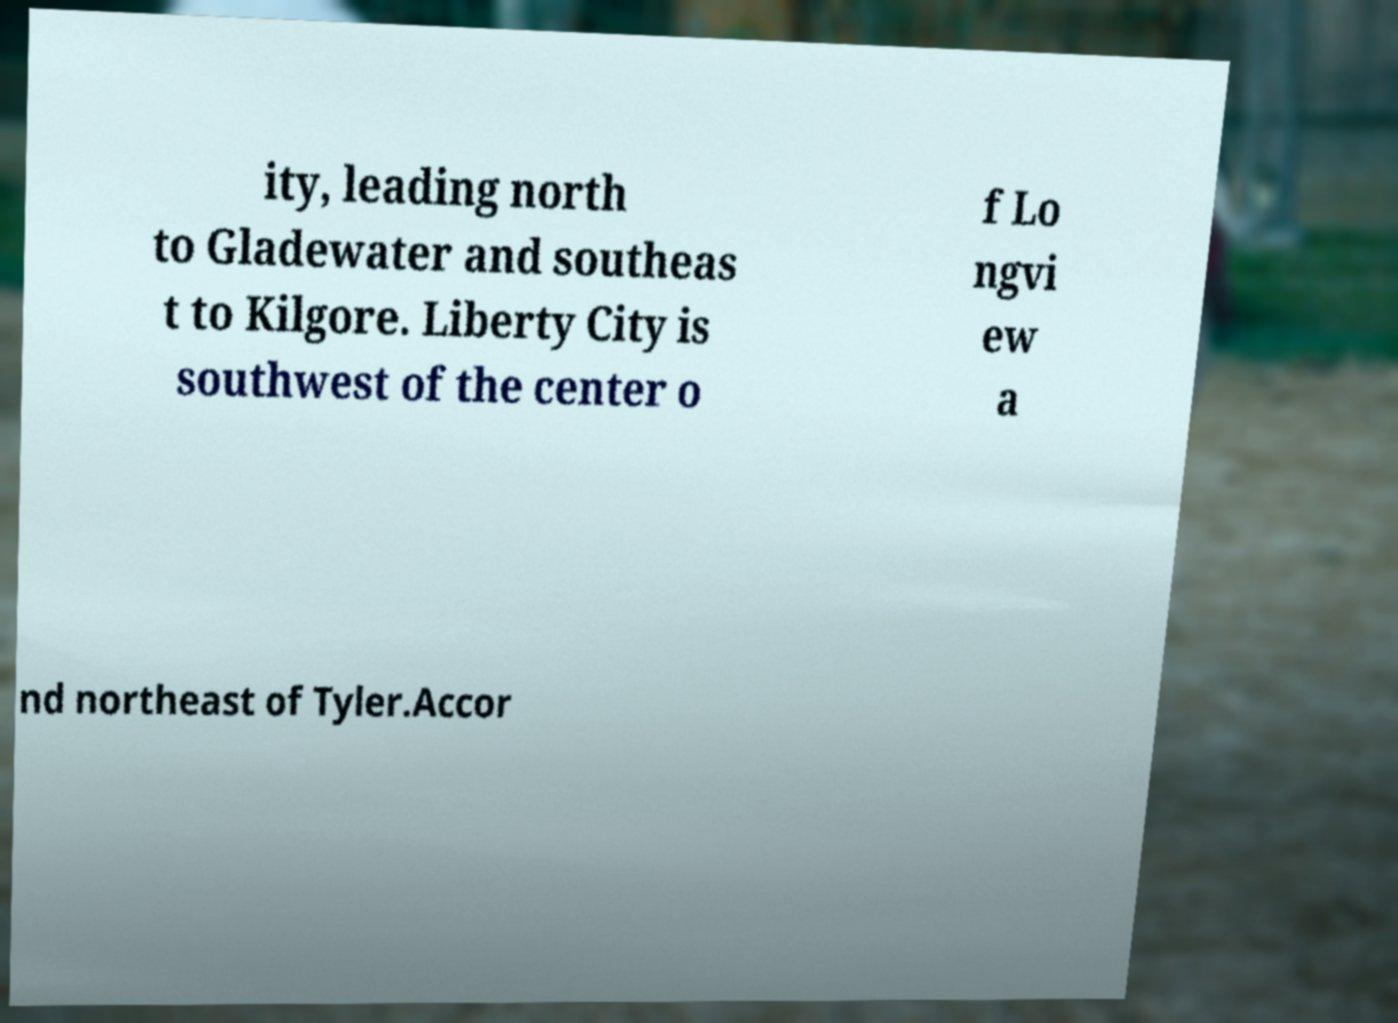Can you accurately transcribe the text from the provided image for me? ity, leading north to Gladewater and southeas t to Kilgore. Liberty City is southwest of the center o f Lo ngvi ew a nd northeast of Tyler.Accor 